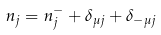Convert formula to latex. <formula><loc_0><loc_0><loc_500><loc_500>n _ { j } = n _ { j } ^ { - } + \delta _ { \mu j } + \delta _ { - \mu j }</formula> 